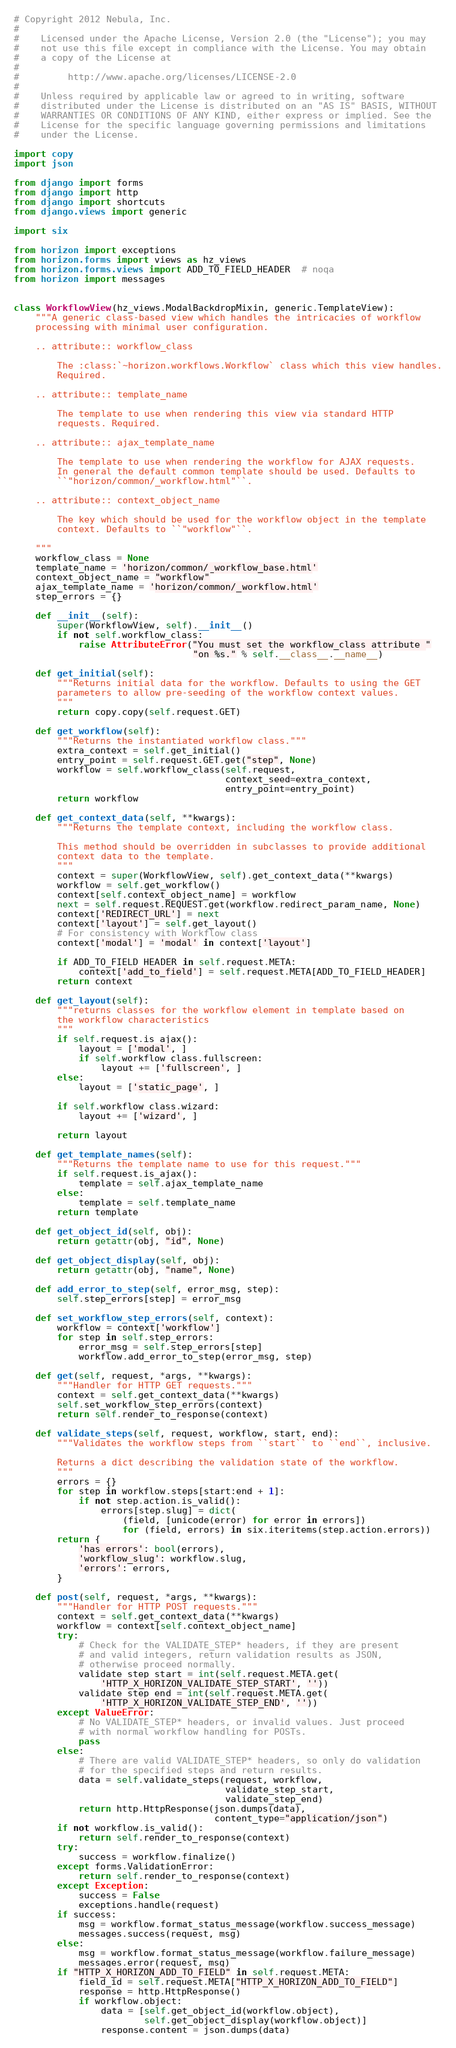Convert code to text. <code><loc_0><loc_0><loc_500><loc_500><_Python_># Copyright 2012 Nebula, Inc.
#
#    Licensed under the Apache License, Version 2.0 (the "License"); you may
#    not use this file except in compliance with the License. You may obtain
#    a copy of the License at
#
#         http://www.apache.org/licenses/LICENSE-2.0
#
#    Unless required by applicable law or agreed to in writing, software
#    distributed under the License is distributed on an "AS IS" BASIS, WITHOUT
#    WARRANTIES OR CONDITIONS OF ANY KIND, either express or implied. See the
#    License for the specific language governing permissions and limitations
#    under the License.

import copy
import json

from django import forms
from django import http
from django import shortcuts
from django.views import generic

import six

from horizon import exceptions
from horizon.forms import views as hz_views
from horizon.forms.views import ADD_TO_FIELD_HEADER  # noqa
from horizon import messages


class WorkflowView(hz_views.ModalBackdropMixin, generic.TemplateView):
    """A generic class-based view which handles the intricacies of workflow
    processing with minimal user configuration.

    .. attribute:: workflow_class

        The :class:`~horizon.workflows.Workflow` class which this view handles.
        Required.

    .. attribute:: template_name

        The template to use when rendering this view via standard HTTP
        requests. Required.

    .. attribute:: ajax_template_name

        The template to use when rendering the workflow for AJAX requests.
        In general the default common template should be used. Defaults to
        ``"horizon/common/_workflow.html"``.

    .. attribute:: context_object_name

        The key which should be used for the workflow object in the template
        context. Defaults to ``"workflow"``.

    """
    workflow_class = None
    template_name = 'horizon/common/_workflow_base.html'
    context_object_name = "workflow"
    ajax_template_name = 'horizon/common/_workflow.html'
    step_errors = {}

    def __init__(self):
        super(WorkflowView, self).__init__()
        if not self.workflow_class:
            raise AttributeError("You must set the workflow_class attribute "
                                 "on %s." % self.__class__.__name__)

    def get_initial(self):
        """Returns initial data for the workflow. Defaults to using the GET
        parameters to allow pre-seeding of the workflow context values.
        """
        return copy.copy(self.request.GET)

    def get_workflow(self):
        """Returns the instantiated workflow class."""
        extra_context = self.get_initial()
        entry_point = self.request.GET.get("step", None)
        workflow = self.workflow_class(self.request,
                                       context_seed=extra_context,
                                       entry_point=entry_point)
        return workflow

    def get_context_data(self, **kwargs):
        """Returns the template context, including the workflow class.

        This method should be overridden in subclasses to provide additional
        context data to the template.
        """
        context = super(WorkflowView, self).get_context_data(**kwargs)
        workflow = self.get_workflow()
        context[self.context_object_name] = workflow
        next = self.request.REQUEST.get(workflow.redirect_param_name, None)
        context['REDIRECT_URL'] = next
        context['layout'] = self.get_layout()
        # For consistency with Workflow class
        context['modal'] = 'modal' in context['layout']

        if ADD_TO_FIELD_HEADER in self.request.META:
            context['add_to_field'] = self.request.META[ADD_TO_FIELD_HEADER]
        return context

    def get_layout(self):
        """returns classes for the workflow element in template based on
        the workflow characteristics
        """
        if self.request.is_ajax():
            layout = ['modal', ]
            if self.workflow_class.fullscreen:
                layout += ['fullscreen', ]
        else:
            layout = ['static_page', ]

        if self.workflow_class.wizard:
            layout += ['wizard', ]

        return layout

    def get_template_names(self):
        """Returns the template name to use for this request."""
        if self.request.is_ajax():
            template = self.ajax_template_name
        else:
            template = self.template_name
        return template

    def get_object_id(self, obj):
        return getattr(obj, "id", None)

    def get_object_display(self, obj):
        return getattr(obj, "name", None)

    def add_error_to_step(self, error_msg, step):
        self.step_errors[step] = error_msg

    def set_workflow_step_errors(self, context):
        workflow = context['workflow']
        for step in self.step_errors:
            error_msg = self.step_errors[step]
            workflow.add_error_to_step(error_msg, step)

    def get(self, request, *args, **kwargs):
        """Handler for HTTP GET requests."""
        context = self.get_context_data(**kwargs)
        self.set_workflow_step_errors(context)
        return self.render_to_response(context)

    def validate_steps(self, request, workflow, start, end):
        """Validates the workflow steps from ``start`` to ``end``, inclusive.

        Returns a dict describing the validation state of the workflow.
        """
        errors = {}
        for step in workflow.steps[start:end + 1]:
            if not step.action.is_valid():
                errors[step.slug] = dict(
                    (field, [unicode(error) for error in errors])
                    for (field, errors) in six.iteritems(step.action.errors))
        return {
            'has_errors': bool(errors),
            'workflow_slug': workflow.slug,
            'errors': errors,
        }

    def post(self, request, *args, **kwargs):
        """Handler for HTTP POST requests."""
        context = self.get_context_data(**kwargs)
        workflow = context[self.context_object_name]
        try:
            # Check for the VALIDATE_STEP* headers, if they are present
            # and valid integers, return validation results as JSON,
            # otherwise proceed normally.
            validate_step_start = int(self.request.META.get(
                'HTTP_X_HORIZON_VALIDATE_STEP_START', ''))
            validate_step_end = int(self.request.META.get(
                'HTTP_X_HORIZON_VALIDATE_STEP_END', ''))
        except ValueError:
            # No VALIDATE_STEP* headers, or invalid values. Just proceed
            # with normal workflow handling for POSTs.
            pass
        else:
            # There are valid VALIDATE_STEP* headers, so only do validation
            # for the specified steps and return results.
            data = self.validate_steps(request, workflow,
                                       validate_step_start,
                                       validate_step_end)
            return http.HttpResponse(json.dumps(data),
                                     content_type="application/json")
        if not workflow.is_valid():
            return self.render_to_response(context)
        try:
            success = workflow.finalize()
        except forms.ValidationError:
            return self.render_to_response(context)
        except Exception:
            success = False
            exceptions.handle(request)
        if success:
            msg = workflow.format_status_message(workflow.success_message)
            messages.success(request, msg)
        else:
            msg = workflow.format_status_message(workflow.failure_message)
            messages.error(request, msg)
        if "HTTP_X_HORIZON_ADD_TO_FIELD" in self.request.META:
            field_id = self.request.META["HTTP_X_HORIZON_ADD_TO_FIELD"]
            response = http.HttpResponse()
            if workflow.object:
                data = [self.get_object_id(workflow.object),
                        self.get_object_display(workflow.object)]
                response.content = json.dumps(data)</code> 